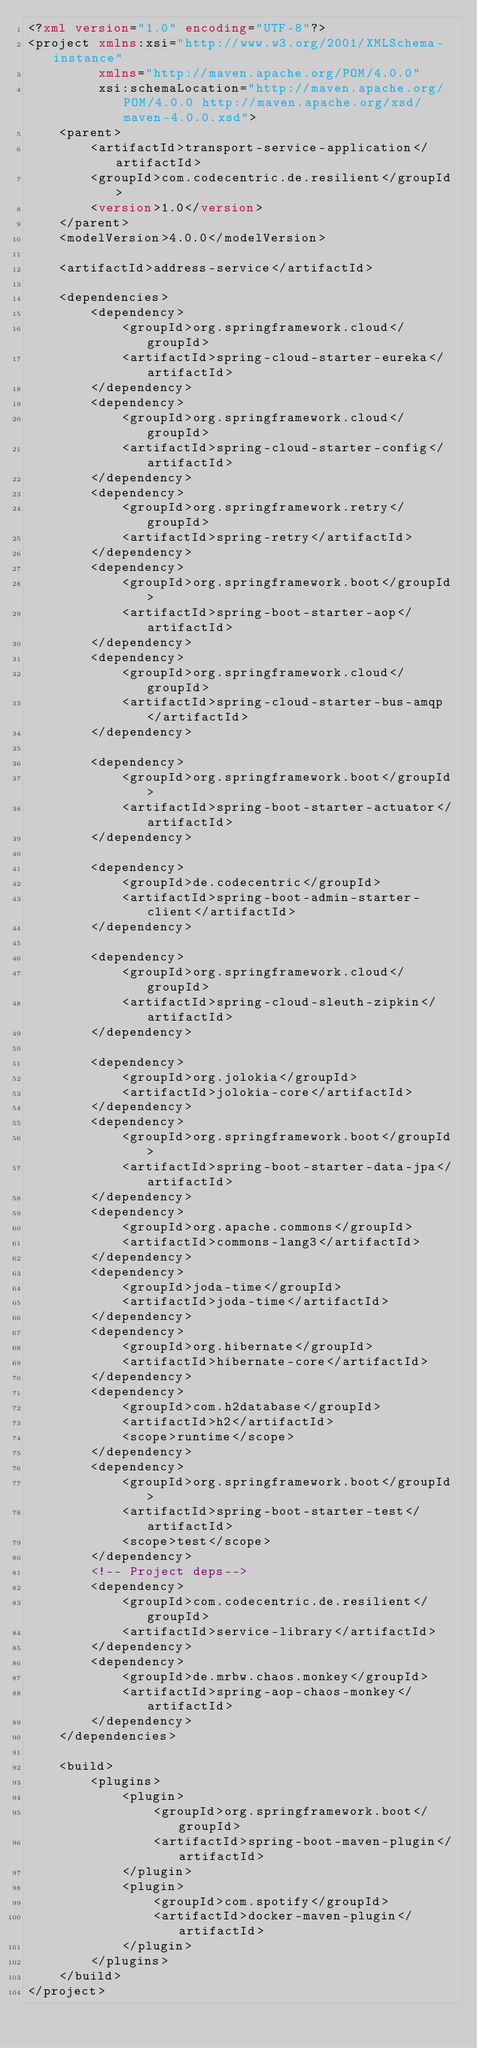<code> <loc_0><loc_0><loc_500><loc_500><_XML_><?xml version="1.0" encoding="UTF-8"?>
<project xmlns:xsi="http://www.w3.org/2001/XMLSchema-instance"
         xmlns="http://maven.apache.org/POM/4.0.0"
         xsi:schemaLocation="http://maven.apache.org/POM/4.0.0 http://maven.apache.org/xsd/maven-4.0.0.xsd">
    <parent>
        <artifactId>transport-service-application</artifactId>
        <groupId>com.codecentric.de.resilient</groupId>
        <version>1.0</version>
    </parent>
    <modelVersion>4.0.0</modelVersion>

    <artifactId>address-service</artifactId>

    <dependencies>
        <dependency>
            <groupId>org.springframework.cloud</groupId>
            <artifactId>spring-cloud-starter-eureka</artifactId>
        </dependency>
        <dependency>
            <groupId>org.springframework.cloud</groupId>
            <artifactId>spring-cloud-starter-config</artifactId>
        </dependency>
        <dependency>
            <groupId>org.springframework.retry</groupId>
            <artifactId>spring-retry</artifactId>
        </dependency>
        <dependency>
            <groupId>org.springframework.boot</groupId>
            <artifactId>spring-boot-starter-aop</artifactId>
        </dependency>
        <dependency>
            <groupId>org.springframework.cloud</groupId>
            <artifactId>spring-cloud-starter-bus-amqp</artifactId>
        </dependency>

        <dependency>
            <groupId>org.springframework.boot</groupId>
            <artifactId>spring-boot-starter-actuator</artifactId>
        </dependency>

        <dependency>
            <groupId>de.codecentric</groupId>
            <artifactId>spring-boot-admin-starter-client</artifactId>
        </dependency>

        <dependency>
            <groupId>org.springframework.cloud</groupId>
            <artifactId>spring-cloud-sleuth-zipkin</artifactId>
        </dependency>

        <dependency>
            <groupId>org.jolokia</groupId>
            <artifactId>jolokia-core</artifactId>
        </dependency>
        <dependency>
            <groupId>org.springframework.boot</groupId>
            <artifactId>spring-boot-starter-data-jpa</artifactId>
        </dependency>
        <dependency>
            <groupId>org.apache.commons</groupId>
            <artifactId>commons-lang3</artifactId>
        </dependency>
        <dependency>
            <groupId>joda-time</groupId>
            <artifactId>joda-time</artifactId>
        </dependency>
        <dependency>
            <groupId>org.hibernate</groupId>
            <artifactId>hibernate-core</artifactId>
        </dependency>
        <dependency>
            <groupId>com.h2database</groupId>
            <artifactId>h2</artifactId>
            <scope>runtime</scope>
        </dependency>
        <dependency>
            <groupId>org.springframework.boot</groupId>
            <artifactId>spring-boot-starter-test</artifactId>
            <scope>test</scope>
        </dependency>
        <!-- Project deps-->
        <dependency>
            <groupId>com.codecentric.de.resilient</groupId>
            <artifactId>service-library</artifactId>
        </dependency>
        <dependency>
            <groupId>de.mrbw.chaos.monkey</groupId>
            <artifactId>spring-aop-chaos-monkey</artifactId>
        </dependency>
    </dependencies>

    <build>
        <plugins>
            <plugin>
                <groupId>org.springframework.boot</groupId>
                <artifactId>spring-boot-maven-plugin</artifactId>
            </plugin>
            <plugin>
                <groupId>com.spotify</groupId>
                <artifactId>docker-maven-plugin</artifactId>
            </plugin>
        </plugins>
    </build>
</project></code> 